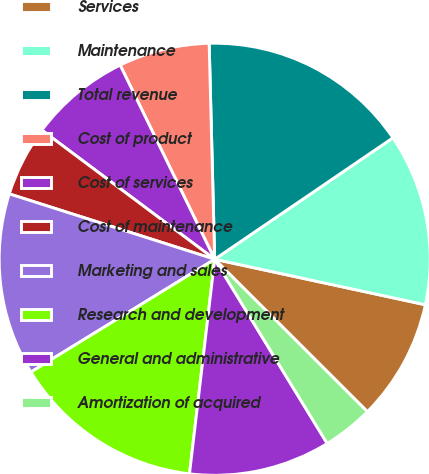Convert chart to OTSL. <chart><loc_0><loc_0><loc_500><loc_500><pie_chart><fcel>Services<fcel>Maintenance<fcel>Total revenue<fcel>Cost of product<fcel>Cost of services<fcel>Cost of maintenance<fcel>Marketing and sales<fcel>Research and development<fcel>General and administrative<fcel>Amortization of acquired<nl><fcel>9.09%<fcel>12.88%<fcel>15.91%<fcel>6.82%<fcel>7.58%<fcel>5.3%<fcel>13.64%<fcel>14.39%<fcel>10.61%<fcel>3.79%<nl></chart> 